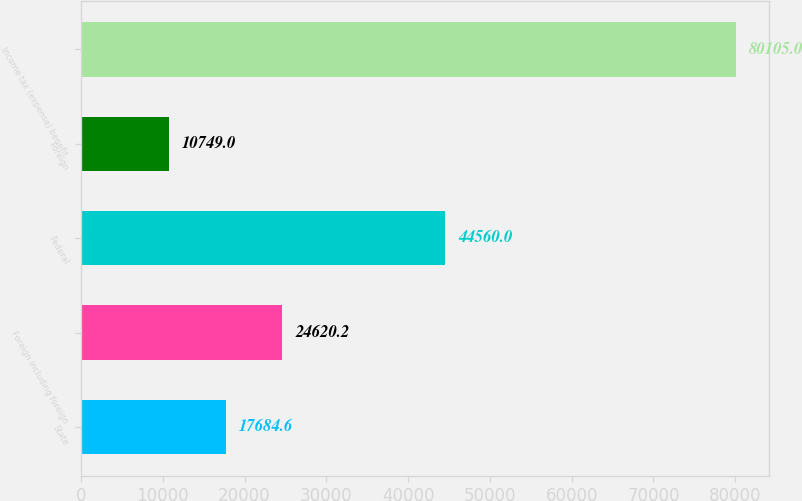Convert chart. <chart><loc_0><loc_0><loc_500><loc_500><bar_chart><fcel>State<fcel>Foreign including foreign<fcel>Federal<fcel>Foreign<fcel>Income tax (expense) benefit<nl><fcel>17684.6<fcel>24620.2<fcel>44560<fcel>10749<fcel>80105<nl></chart> 